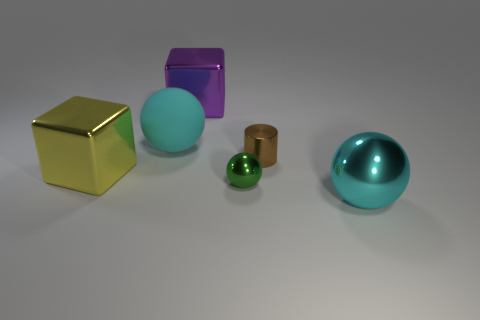Add 4 tiny brown objects. How many objects exist? 10 Subtract all cylinders. How many objects are left? 5 Subtract all cylinders. Subtract all large rubber things. How many objects are left? 4 Add 5 big purple objects. How many big purple objects are left? 6 Add 4 cyan rubber objects. How many cyan rubber objects exist? 5 Subtract 0 purple cylinders. How many objects are left? 6 